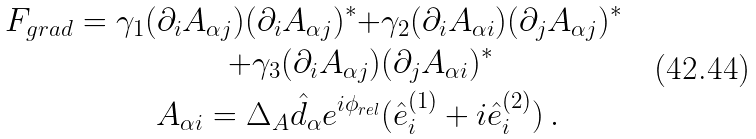Convert formula to latex. <formula><loc_0><loc_0><loc_500><loc_500>F _ { g r a d } = \gamma _ { 1 } ( \partial _ { i } A _ { \alpha j } ) ( \partial _ { i } A _ { \alpha j } ) ^ { * } + & \gamma _ { 2 } ( \partial _ { i } A _ { \alpha i } ) ( \partial _ { j } A _ { \alpha j } ) ^ { * } \\ + \gamma _ { 3 } ( \partial _ { i } A _ { \alpha j } ) & ( \partial _ { j } A _ { \alpha i } ) ^ { * } \\ A _ { \alpha i } = \Delta _ { A } \hat { d } _ { \alpha } e ^ { i \phi _ { r e l } } & ( \hat { e } ^ { ( 1 ) } _ { i } + i \hat { e } ^ { ( 2 ) } _ { i } ) \, .</formula> 